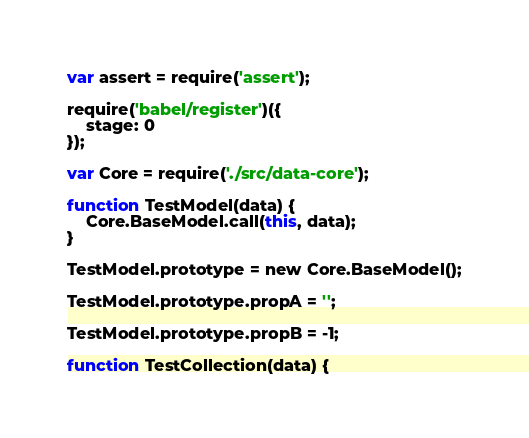<code> <loc_0><loc_0><loc_500><loc_500><_JavaScript_>var assert = require('assert');

require('babel/register')({
    stage: 0
});

var Core = require('./src/data-core');

function TestModel(data) {
    Core.BaseModel.call(this, data);
}

TestModel.prototype = new Core.BaseModel();

TestModel.prototype.propA = '';

TestModel.prototype.propB = -1;

function TestCollection(data) {</code> 